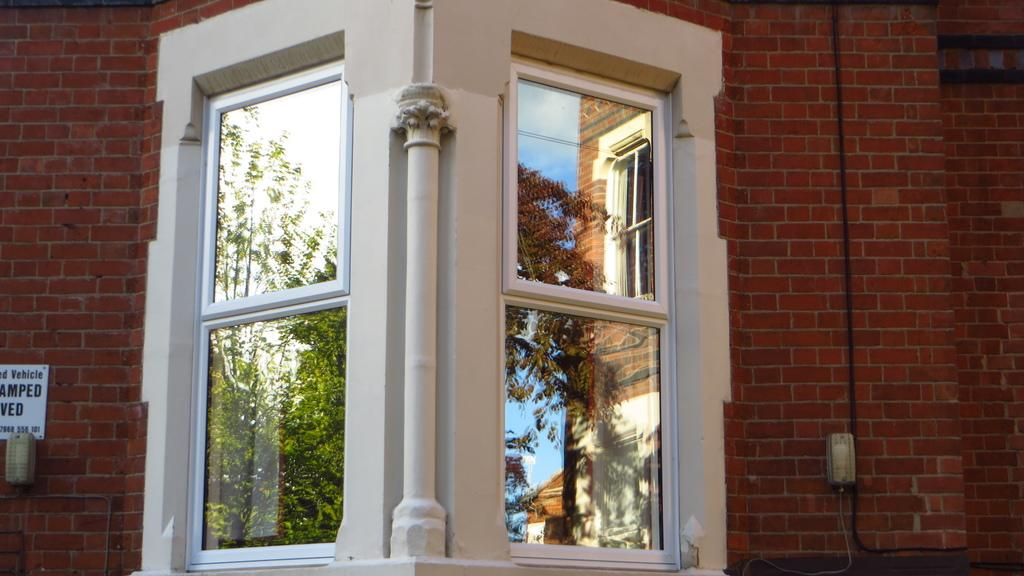What can be seen on the left side of the image? There is a window on the left side of the image. What else is present on the left side of the image? There is a brick wall on the extreme left side of the image. What can be seen on the right side of the image? There is a window on the right side of the image. What else is present on the right side of the image? There is a brick wall on the extreme right side of the image. How many trees are visible in the image? There are no trees visible in the image; it features windows and brick walls. What type of library is shown in the image? There is no library present in the image; it only shows windows and brick walls. 